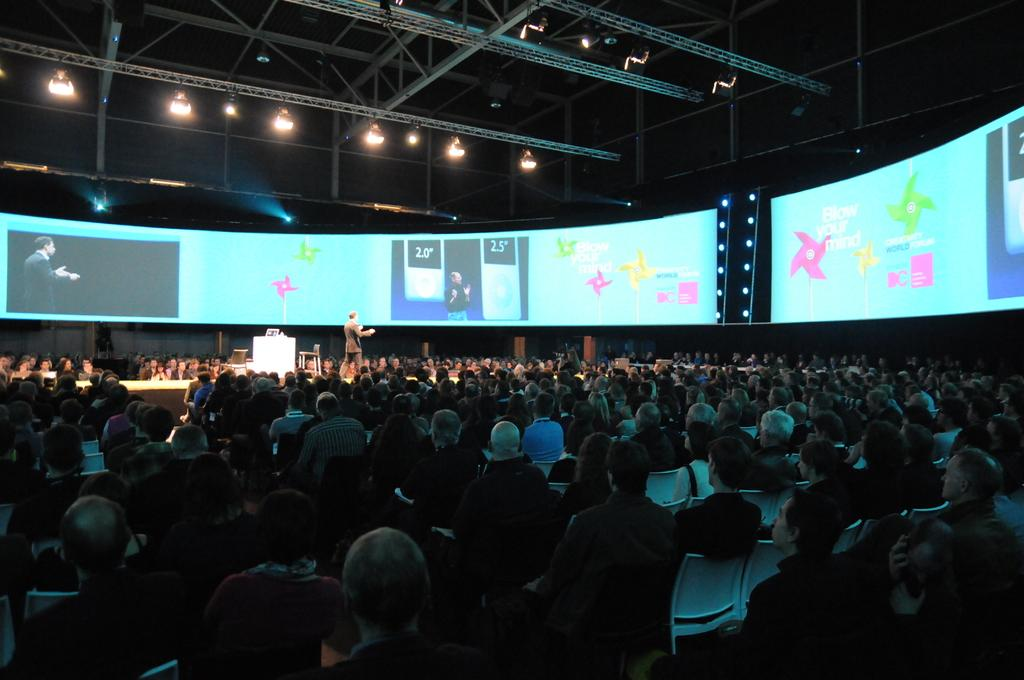What is the arrangement of people in the image? There is a crowd sitting on chairs in the image. What is happening on the stage? There is a person standing on a stage in the image. What furniture is visible in the image? There are chairs and a table in the image. What can be seen in the background of the image? In the background, there are screens, rods, and lights. How many elbows can be seen on the person standing on the stage? There is no information about the person's elbows in the image, so it cannot be determined. What type of ticket is required to enter the event? There is no mention of tickets or an event in the image, so it cannot be determined. 